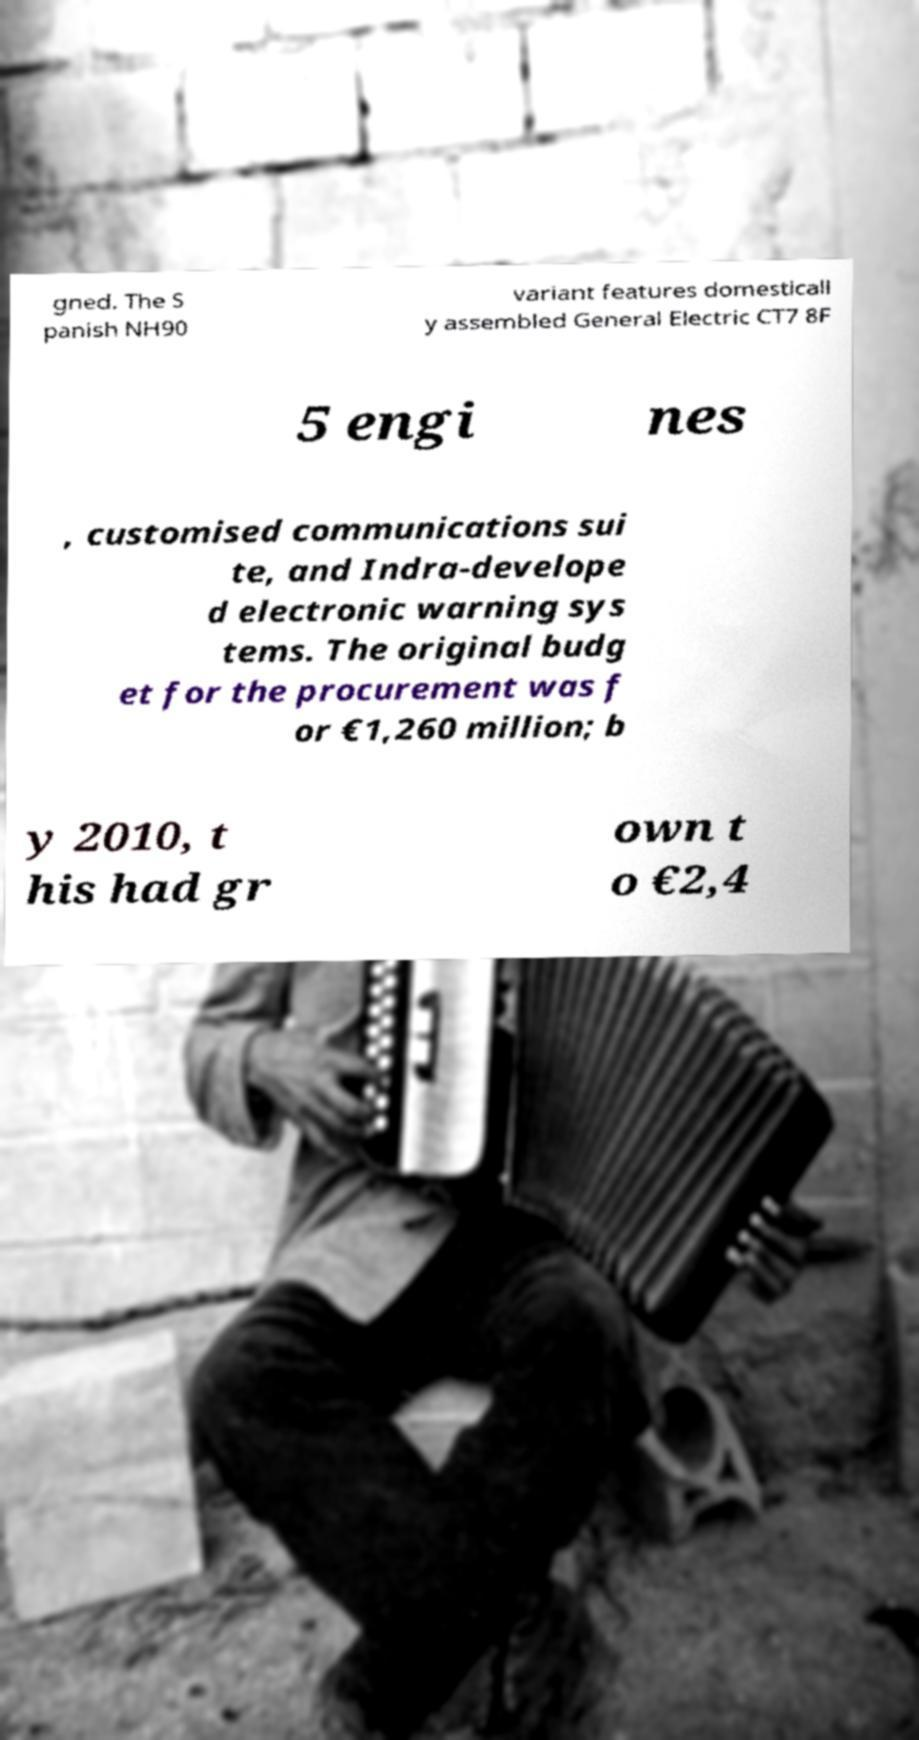I need the written content from this picture converted into text. Can you do that? gned. The S panish NH90 variant features domesticall y assembled General Electric CT7 8F 5 engi nes , customised communications sui te, and Indra-develope d electronic warning sys tems. The original budg et for the procurement was f or €1,260 million; b y 2010, t his had gr own t o €2,4 